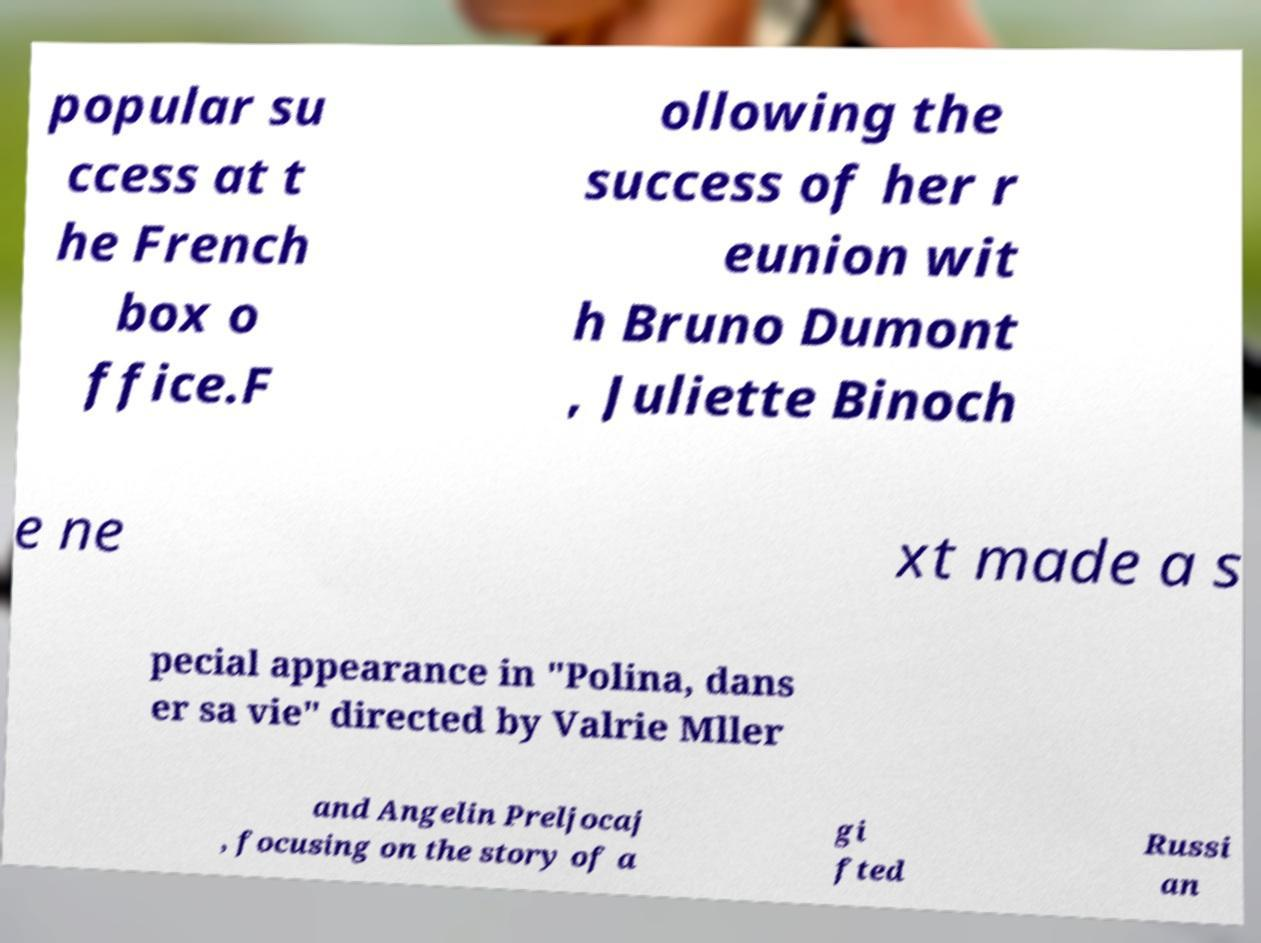Could you extract and type out the text from this image? popular su ccess at t he French box o ffice.F ollowing the success of her r eunion wit h Bruno Dumont , Juliette Binoch e ne xt made a s pecial appearance in "Polina, dans er sa vie" directed by Valrie Mller and Angelin Preljocaj , focusing on the story of a gi fted Russi an 